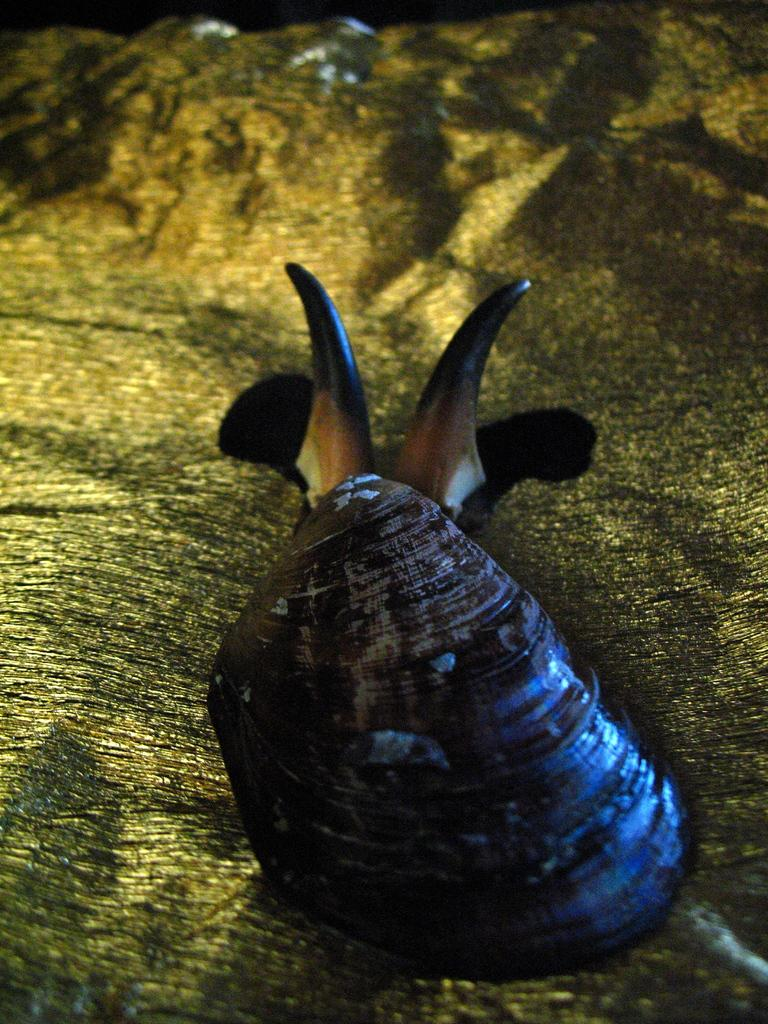What type of animal is in the image? There is a snail in the image. What is the snail resting on in the image? The snail is on a wooden surface. What type of feather is attached to the snail's body in the image? There is no feather present in the image, and the snail's body does not have any attachments. 